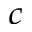<formula> <loc_0><loc_0><loc_500><loc_500>^ { c }</formula> 